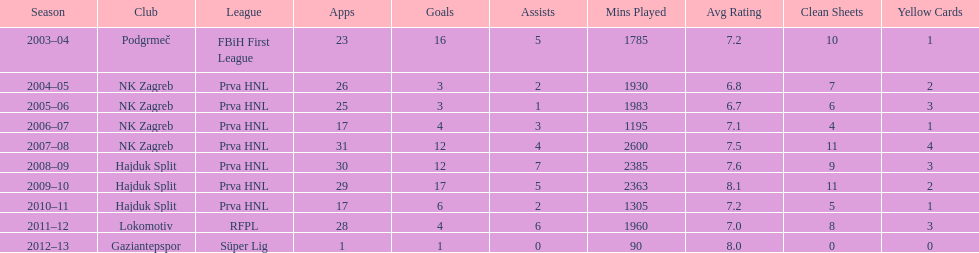What is the highest number of goals scored by senijad ibri&#269;i&#263; in a season? 35. 